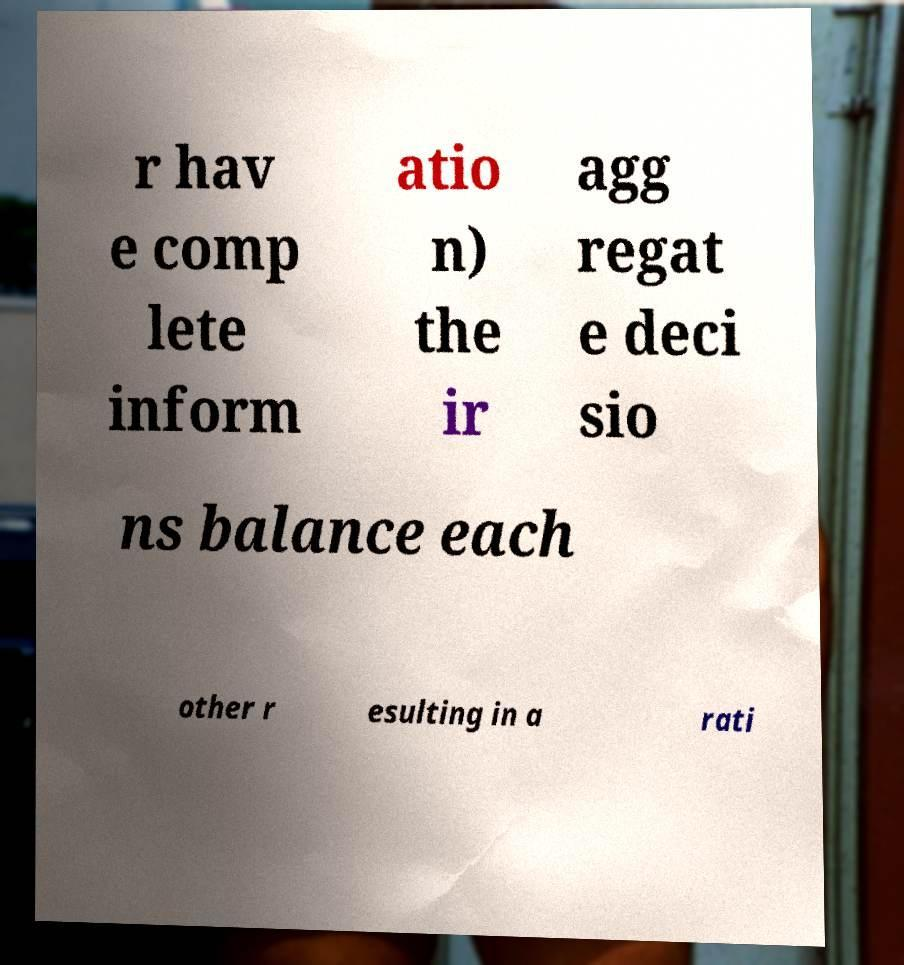Please read and relay the text visible in this image. What does it say? r hav e comp lete inform atio n) the ir agg regat e deci sio ns balance each other r esulting in a rati 